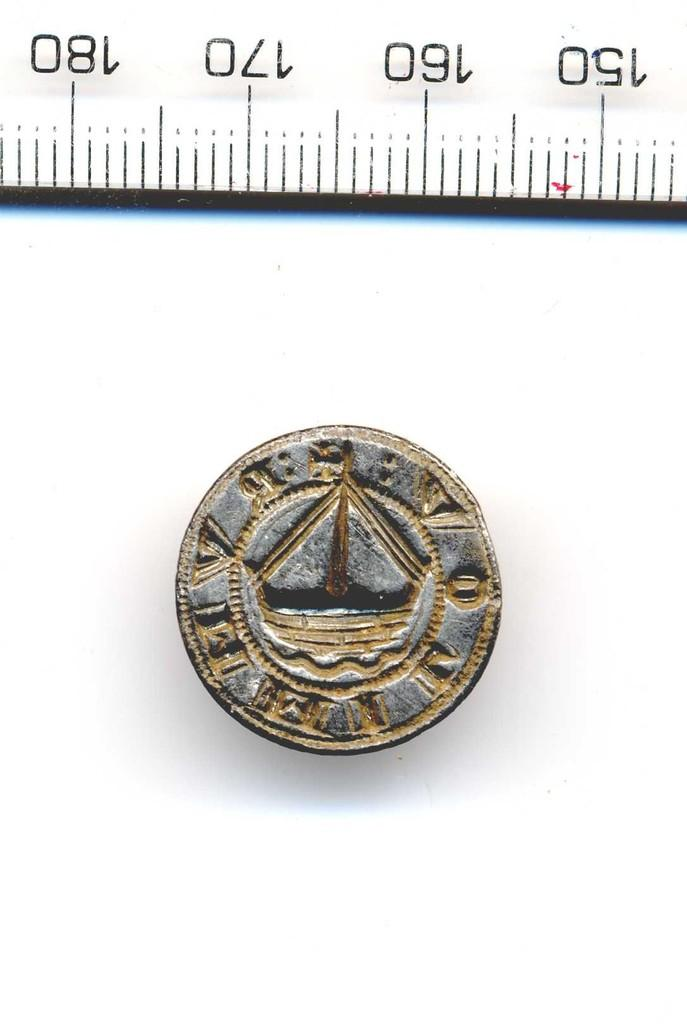<image>
Share a concise interpretation of the image provided. Gold coin right under some numbers on a ruler that say 160 and 170. 